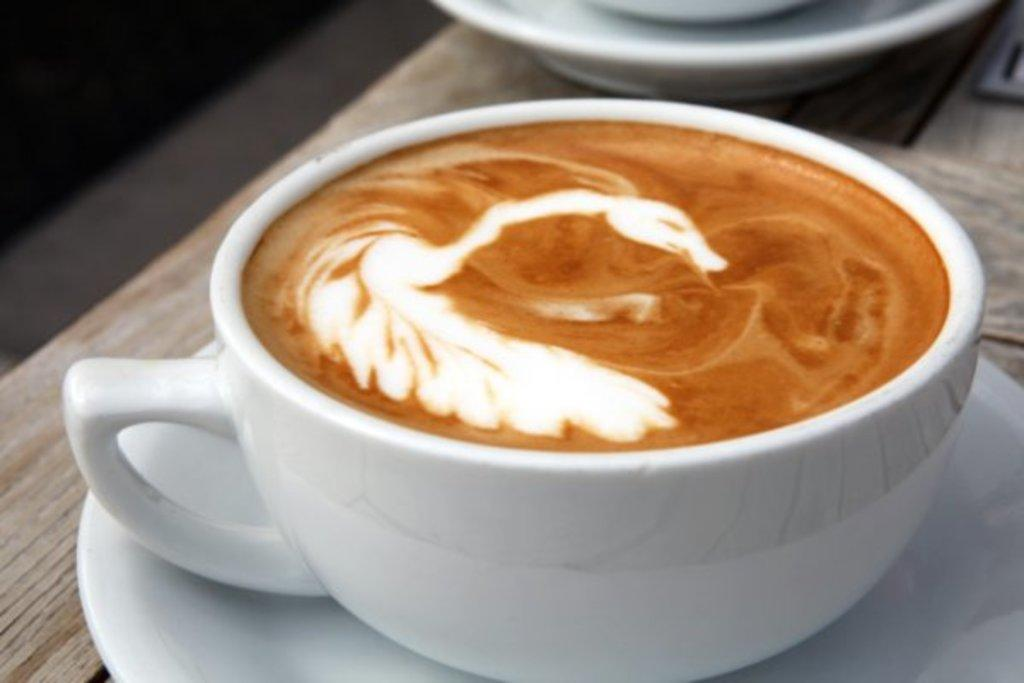What is on the wooden table in the image? There is a coffee cup with sauce on a wooden table. Are there any other coffee cups visible in the image? Yes, there is another coffee cup with a saucer beside it. Can you see a hen laying a pickle in the image? No, there is no hen or pickle present in the image. 